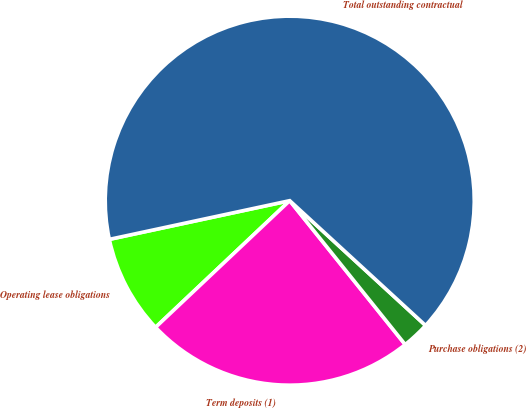Convert chart to OTSL. <chart><loc_0><loc_0><loc_500><loc_500><pie_chart><fcel>Operating lease obligations<fcel>Term deposits (1)<fcel>Purchase obligations (2)<fcel>Total outstanding contractual<nl><fcel>8.68%<fcel>23.72%<fcel>2.41%<fcel>65.19%<nl></chart> 